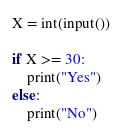<code> <loc_0><loc_0><loc_500><loc_500><_Python_>X = int(input())

if X >= 30:
    print("Yes")
else:
    print("No")</code> 